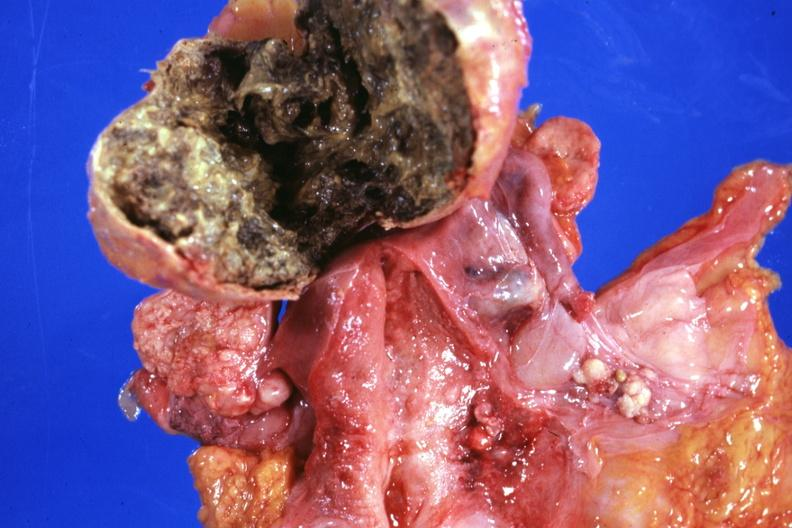what is present?
Answer the question using a single word or phrase. Ovary 